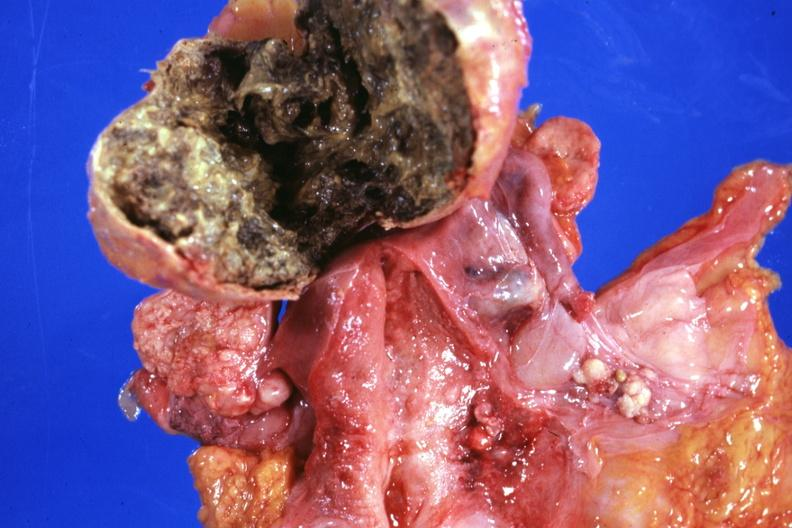what is present?
Answer the question using a single word or phrase. Ovary 